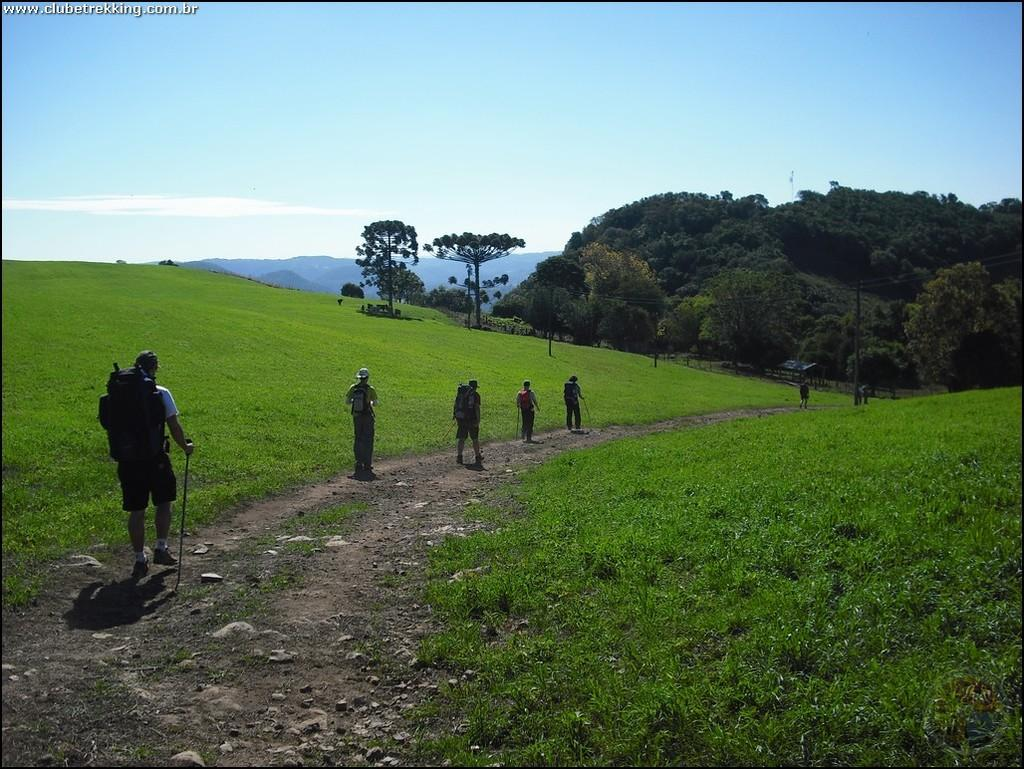How many people are in the image? There are people in the image, but the exact number is not specified. What are the people wearing in the image? The people are wearing bags in the image. What are the people doing in the image? The people are walking in the image. What type of vegetation is present in the image? There are trees in the image. What is the terrain like in the image? There is a hill and grass in the image, suggesting a hilly or grassy terrain. What is visible at the top of the image? The sky is visible at the top of the image. What type of cup can be seen in the hands of the people walking in the image? There is no cup visible in the hands of the people walking in the image. Can you describe the behavior of the ants in the image? There are no ants present in the image. 